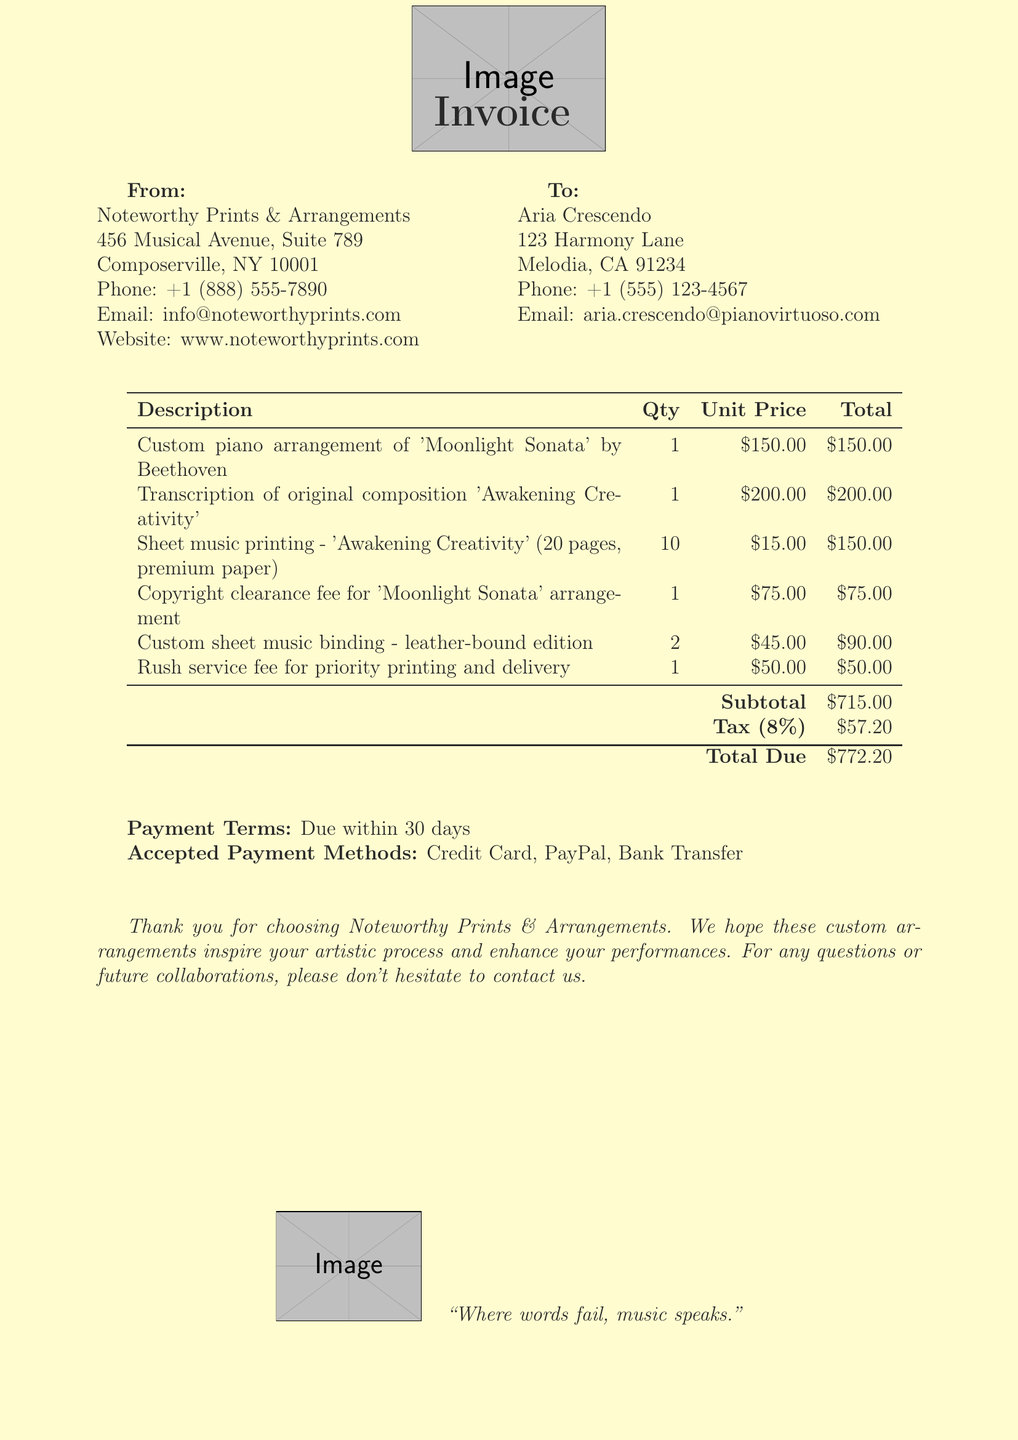What is the name of the client? The client's name is listed in the document under client info.
Answer: Aria Crescendo How much is the rush service fee? The rush service fee is specified among the invoice items with its unit price.
Answer: $50.00 What is the quantity of the custom sheet music binding? The quantity for the custom sheet music binding is provided in the invoice items section.
Answer: 2 What is the subtotal amount before tax? The subtotal reflects the total amount before tax is added, detailed in the payment section.
Answer: $715.00 Who is the service provider? The service provider's name is prominently displayed at the top of the invoice.
Answer: Noteworthy Prints & Arrangements What is the tax rate applied in the invoice? The tax rate is specified in the payment details section of the document.
Answer: 8% What is the total amount due? The total amount due is calculated at the bottom of the invoice, summarizing all charges.
Answer: $772.20 Is there a copyright clearance fee listed? The invoice includes various fees, including a specific fee for copyright clearance in the items.
Answer: Yes What is the payment term given in the invoice? The payment terms are clearly stated in the document to inform the client of the expectations.
Answer: Due within 30 days 